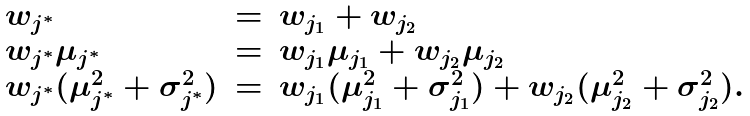<formula> <loc_0><loc_0><loc_500><loc_500>\begin{array} { l l l } w _ { j ^ { * } } & = & w _ { j _ { 1 } } + w _ { j _ { 2 } } \\ w _ { j ^ { * } } \mu _ { j ^ { * } } & = & w _ { j _ { 1 } } \mu _ { j _ { 1 } } + w _ { j _ { 2 } } \mu _ { j _ { 2 } } \\ w _ { j ^ { * } } ( \mu ^ { 2 } _ { j ^ { * } } + \sigma ^ { 2 } _ { j ^ { * } } ) & = & w _ { j _ { 1 } } ( \mu ^ { 2 } _ { j _ { 1 } } + \sigma ^ { 2 } _ { j _ { 1 } } ) + w _ { j _ { 2 } } ( \mu ^ { 2 } _ { j _ { 2 } } + \sigma ^ { 2 } _ { j _ { 2 } } ) . \end{array}</formula> 